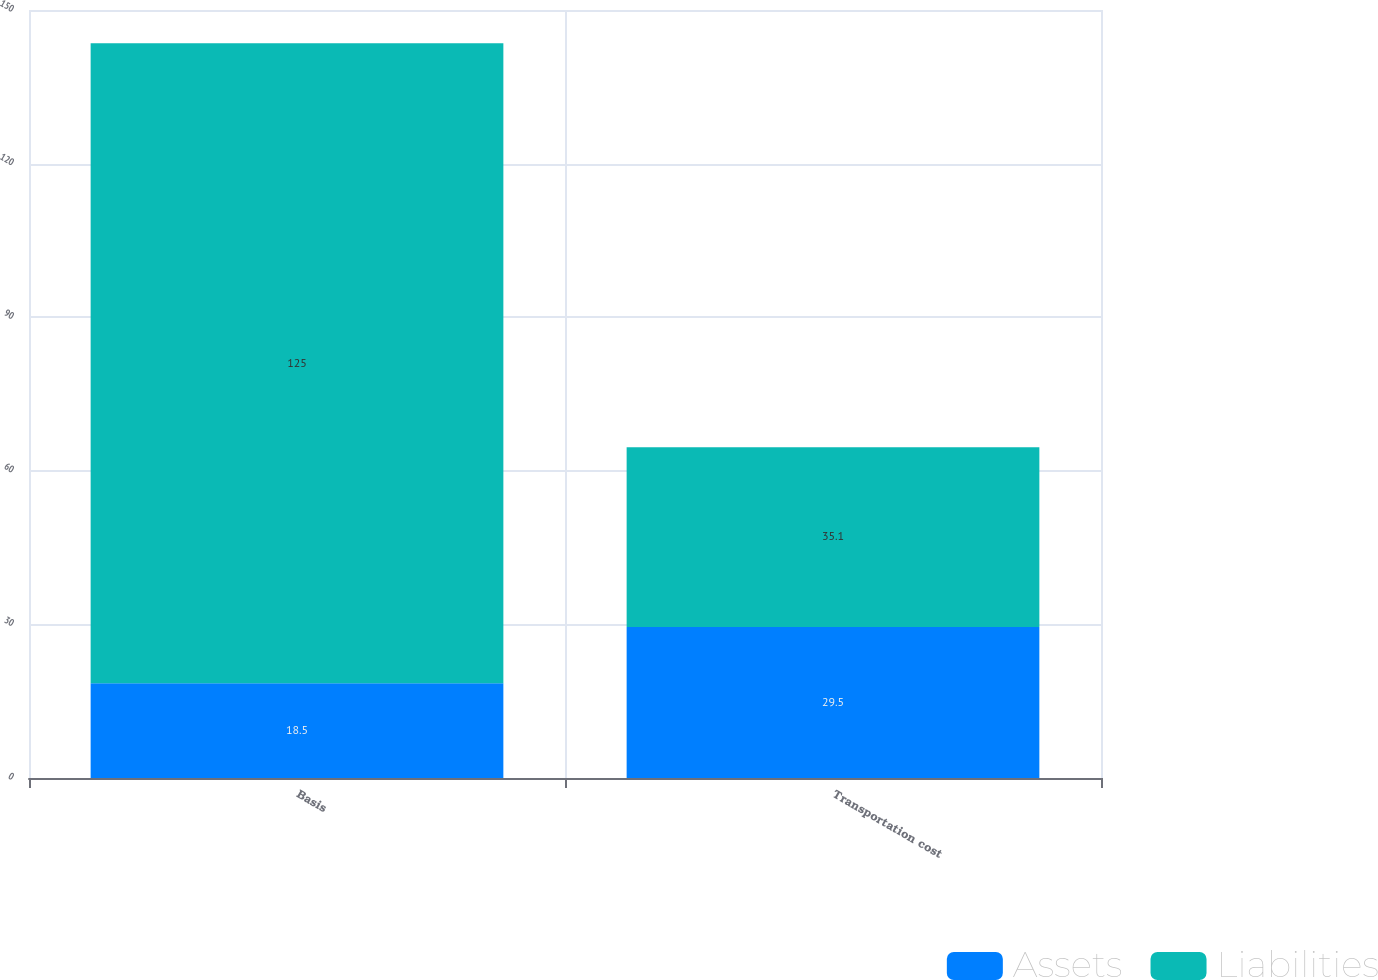Convert chart to OTSL. <chart><loc_0><loc_0><loc_500><loc_500><stacked_bar_chart><ecel><fcel>Basis<fcel>Transportation cost<nl><fcel>Assets<fcel>18.5<fcel>29.5<nl><fcel>Liabilities<fcel>125<fcel>35.1<nl></chart> 